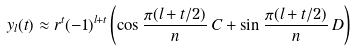Convert formula to latex. <formula><loc_0><loc_0><loc_500><loc_500>y _ { l } ( t ) \approx r ^ { t } ( - 1 ) ^ { l + t } \left ( \cos \frac { \pi ( l + t / 2 ) } { n } \, C + \sin \frac { \pi ( l + t / 2 ) } { n } \, D \right )</formula> 